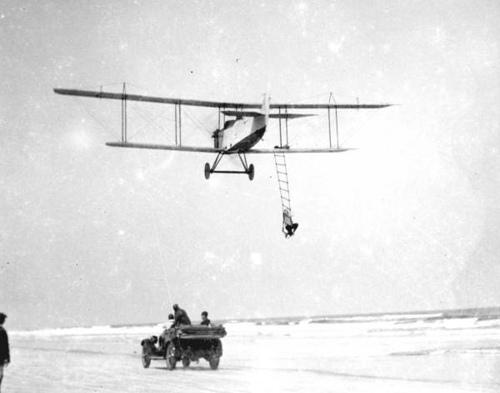How many wheels does the plane have?
Be succinct. 2. What time was the picture taken?
Write a very short answer. Daytime. Will the person fall from the ladder?
Keep it brief. No. Is this a modern airplane?
Write a very short answer. No. 